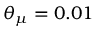<formula> <loc_0><loc_0><loc_500><loc_500>\theta _ { \mu } = 0 . 0 1</formula> 